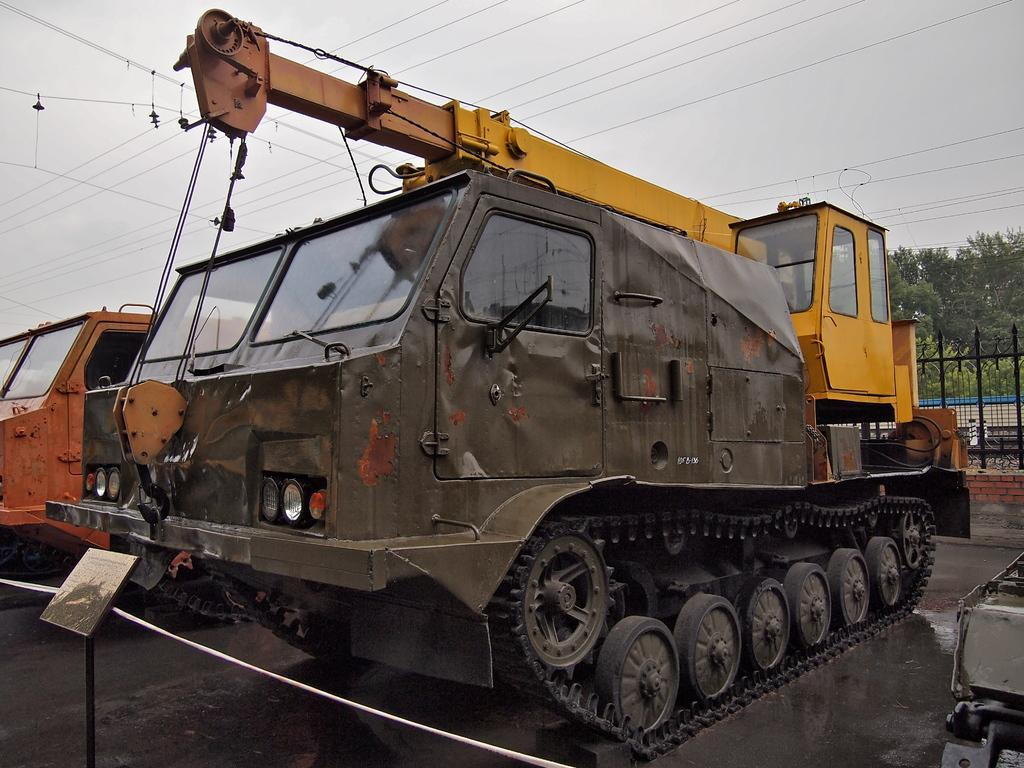What types of vehicles are in the image? There are vehicles in the image, but the specific types are not mentioned. What feature is common to all the vehicles in the image? Wheels are visible in the image, which are a common feature of vehicles. What might be the reason for the road appearing wet in the image? The road appears to be wet in the image, which could be due to rain or recent cleaning. What utility infrastructure is present in the image? Electric wires are present in the image, which are used for transmitting electricity. What type of barrier is present in the image? There is a fence in the image, which serves as a barrier or boundary. What type of natural elements are visible in the image? Trees and the sky are visible in the image, which are natural elements. What time of day is it in the image, based on the hour? The provided facts do not mention the time of day or any specific hour, so it cannot be determined from the image. Is there any snow visible in the image? There is no mention of snow in the provided facts, and it is not visible in the image. 